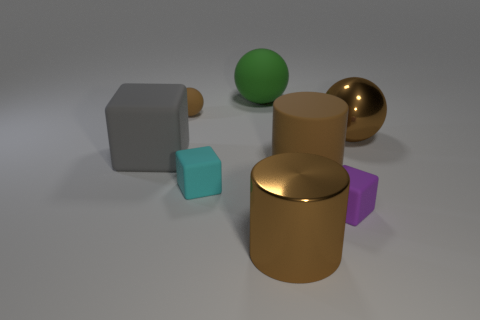Subtract all matte spheres. How many spheres are left? 1 Add 2 large green shiny things. How many objects exist? 10 Subtract all green balls. How many balls are left? 2 Subtract 3 balls. How many balls are left? 0 Subtract all cyan blocks. How many brown balls are left? 2 Add 4 tiny brown matte spheres. How many tiny brown matte spheres exist? 5 Subtract 0 red cylinders. How many objects are left? 8 Subtract all cylinders. How many objects are left? 6 Subtract all purple cubes. Subtract all brown cylinders. How many cubes are left? 2 Subtract all cyan rubber balls. Subtract all cyan rubber blocks. How many objects are left? 7 